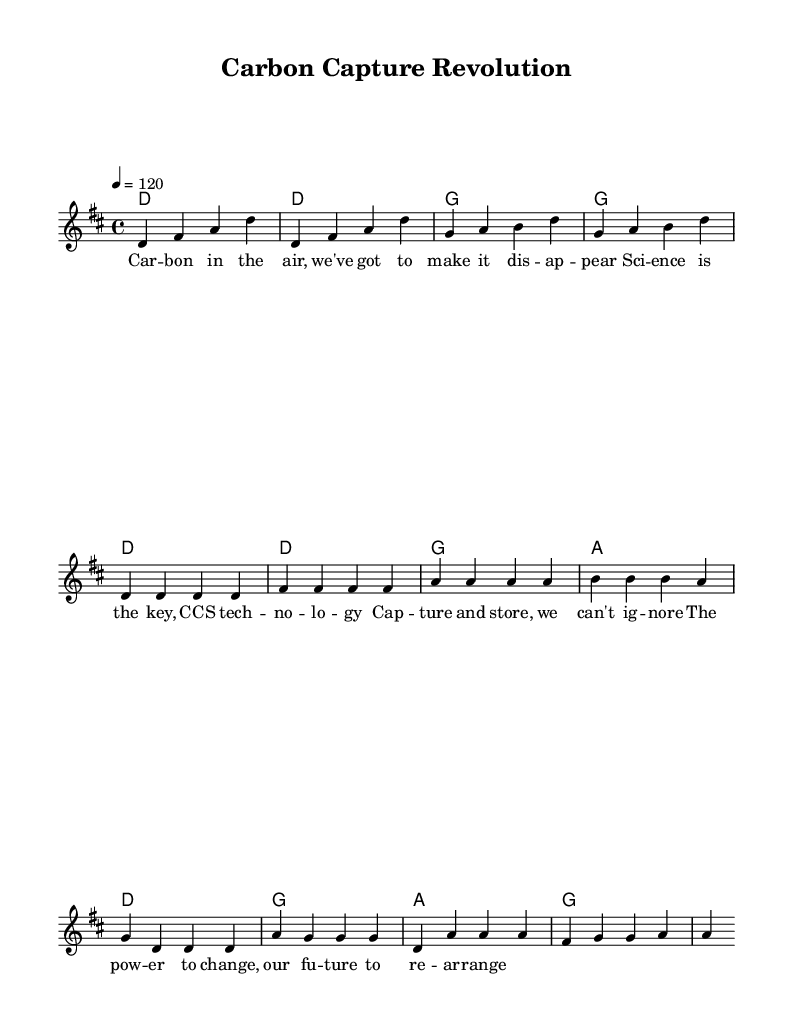What is the key signature of this music? The key signature is indicated by the sharp symbols at the beginning of the staff. In this case, there are two sharps, which indicate that the key is D major.
Answer: D major What is the time signature of this music? The time signature is displayed at the beginning of the music and is represented by the fraction 4/4, which means there are four beats in each measure, and the quarter note gets one beat.
Answer: 4/4 What is the tempo marking for this piece? The tempo marking is shown using a specific notation, "4 = 120," indicating the speed at which the music should be played, meaning there are 120 beats per minute.
Answer: 120 How many measures are in the intro section? The intro is composed of four measures, which can be counted as there are four sets of vertical lines separating the music into distinct sections.
Answer: 4 How many unique chords are used in the chorus? By examining the chord changes in the chorus section, we can see the chords are D, G, and A. Hence, there are three unique chords utilized within the chorus.
Answer: 3 What is the last line of the chorus lyrics? The last line of the chorus can be identified by looking at the lyrics presented underneath the music notes; it ends with "to re-arrange."
Answer: to re-arrange Which section of the song features the lyrics about "science"? The lyrics referencing "science" appear in the verse section, where it discusses the significance of science related to carbon capture technology.
Answer: verse 